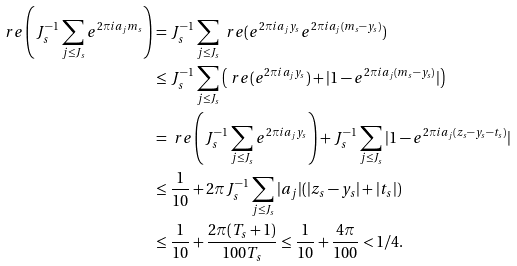<formula> <loc_0><loc_0><loc_500><loc_500>\ r e \left ( J _ { s } ^ { - 1 } \sum _ { j \leq J _ { s } } e ^ { 2 \pi i a _ { j } m _ { s } } \right ) & = J _ { s } ^ { - 1 } \sum _ { j \leq J _ { s } } \ r e ( e ^ { 2 \pi i a _ { j } y _ { s } } e ^ { 2 \pi i a _ { j } ( m _ { s } - y _ { s } ) } ) \\ & \leq J _ { s } ^ { - 1 } \sum _ { j \leq J _ { s } } \left ( \ r e ( e ^ { 2 \pi i a _ { j } y _ { s } } ) + | 1 - e ^ { 2 \pi i a _ { j } ( m _ { s } - y _ { s } ) } | \right ) \\ & = \ r e \left ( J _ { s } ^ { - 1 } \sum _ { j \leq J _ { s } } e ^ { 2 \pi i a _ { j } y _ { s } } \right ) + J _ { s } ^ { - 1 } \sum _ { j \leq J _ { s } } | 1 - e ^ { 2 \pi i a _ { j } ( z _ { s } - y _ { s } - t _ { s } ) } | \\ & \leq \frac { 1 } { 1 0 } + 2 \pi J _ { s } ^ { - 1 } \sum _ { j \leq J _ { s } } | a _ { j } | ( | z _ { s } - y _ { s } | + | t _ { s } | ) \\ & \leq \frac { 1 } { 1 0 } + \frac { 2 \pi ( T _ { s } + 1 ) } { 1 0 0 T _ { s } } \leq \frac { 1 } { 1 0 } + \frac { 4 \pi } { 1 0 0 } < 1 / 4 .</formula> 